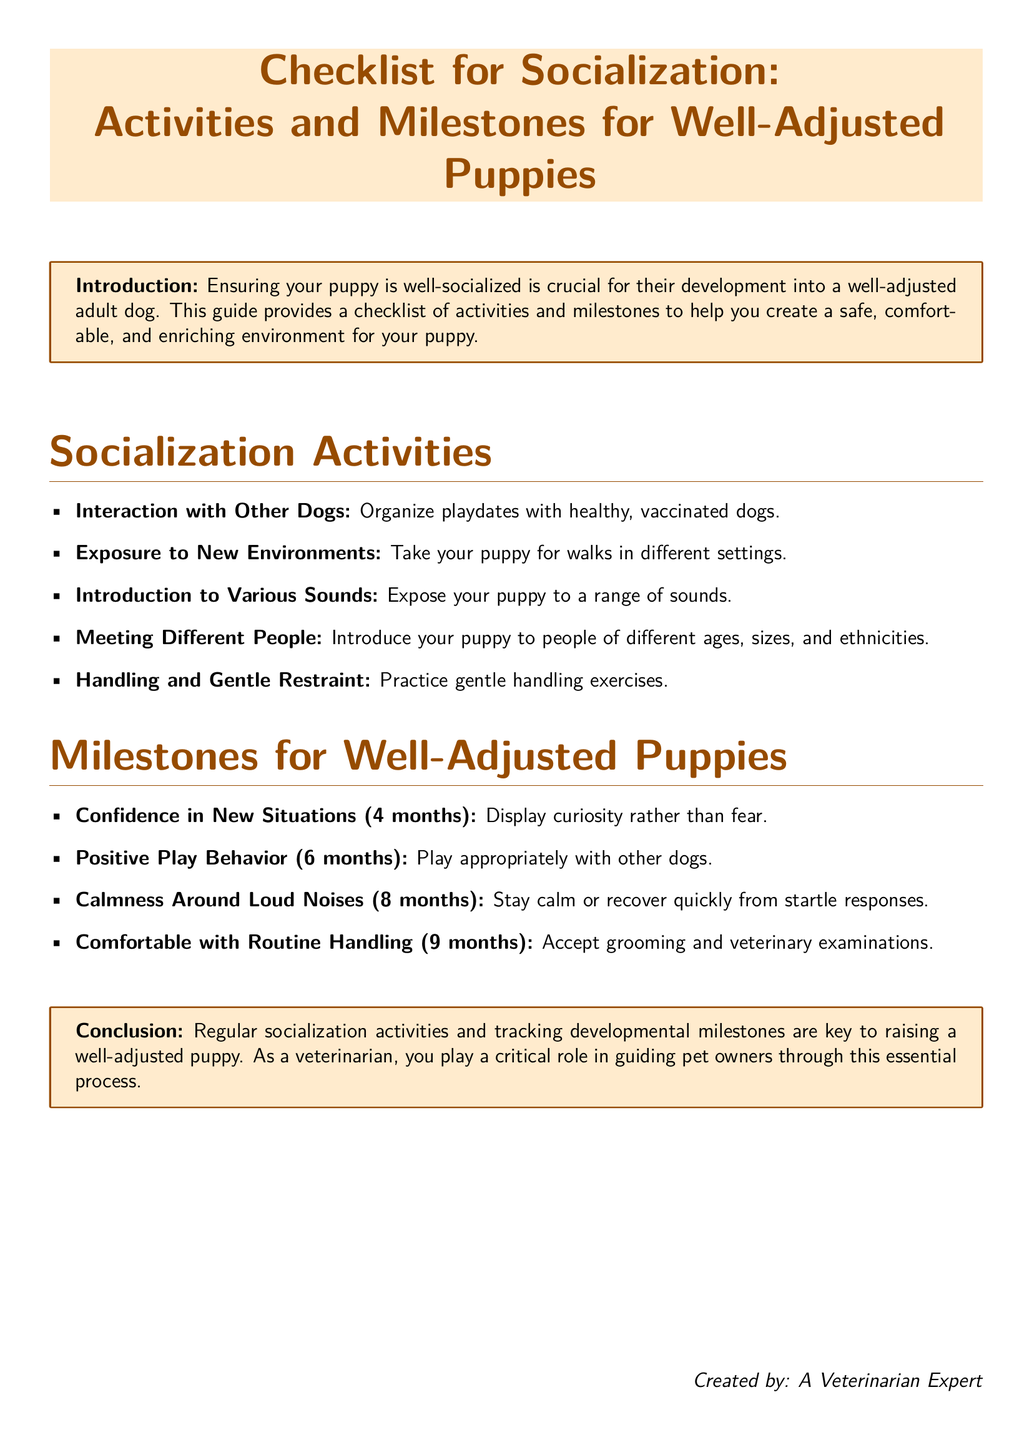what is the title of the document? The title is the main heading of the document, which summarizes its purpose and content.
Answer: Checklist for Socialization: Activities and Milestones for Well-Adjusted Puppies what is the introduction's focus? The introduction explains the importance of socialization for a puppy's development, emphasizing the creation of a safe environment.
Answer: Ensuring your puppy is well-socialized how many months is the puppy expected to display curiosity in new situations? The document specifies a particular age milestone for when a puppy should show curiosity.
Answer: 4 months what activity involves exposure to new environments? The document lists specific activities that help with socialization, including this one.
Answer: Take your puppy for walks in different settings which milestone indicates a puppy is comfortable with routine handling? It is important to track the milestones for the puppy's development, and this indicates a particular achievement.
Answer: 9 months name one way to introduce a puppy to different people. The document outlines activities focusing on socializing with various individuals, highlighting this aspect.
Answer: Introduce your puppy to people of different ages, sizes, and ethnicities which sound-related milestone occurs at 8 months? Understanding the timing of developmental milestones is crucial, and this question addresses a specific one.
Answer: Calmness Around Loud Noises what is the purpose of the checklist? The checklist serves as a guide for specific activities and milestones beneficial for puppy socialization.
Answer: To help you create a safe, comfortable, and enriching environment 